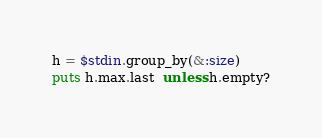<code> <loc_0><loc_0><loc_500><loc_500><_Ruby_>h = $stdin.group_by(&:size)
puts h.max.last  unless h.empty?
</code> 